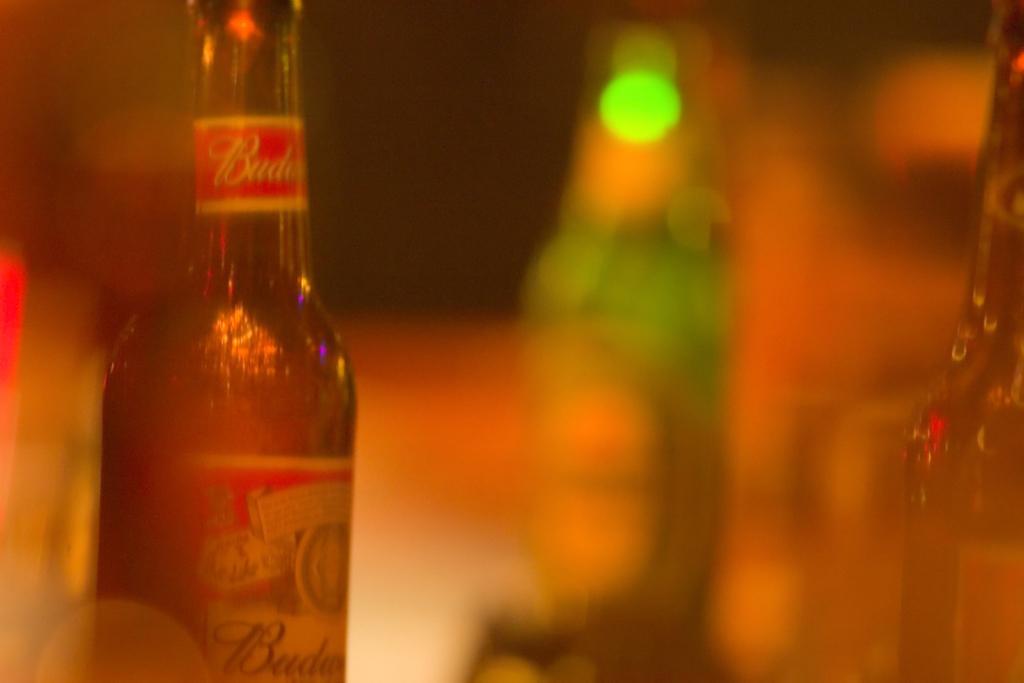Please provide a concise description of this image. In the picture there are many glass bottles. The image is blurred. 